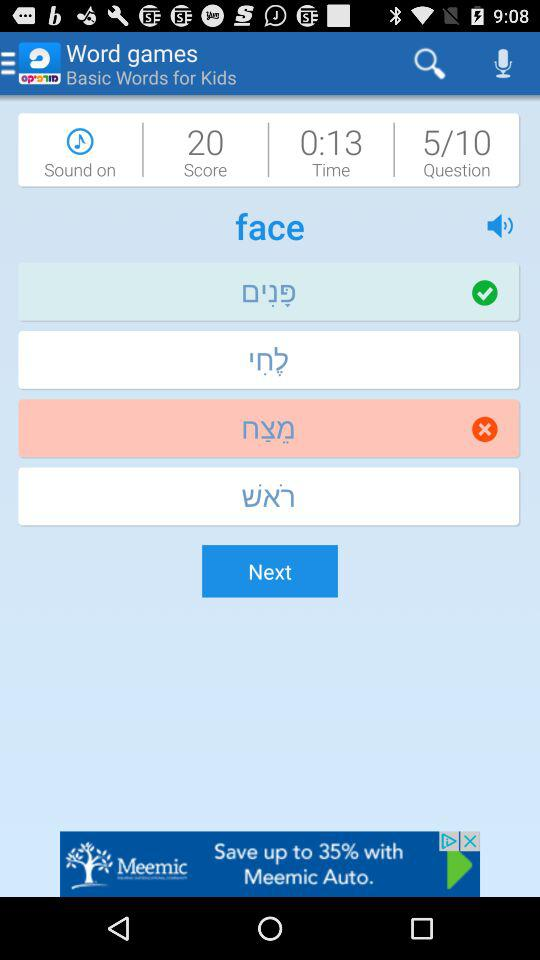What is the score? The score is 20. 